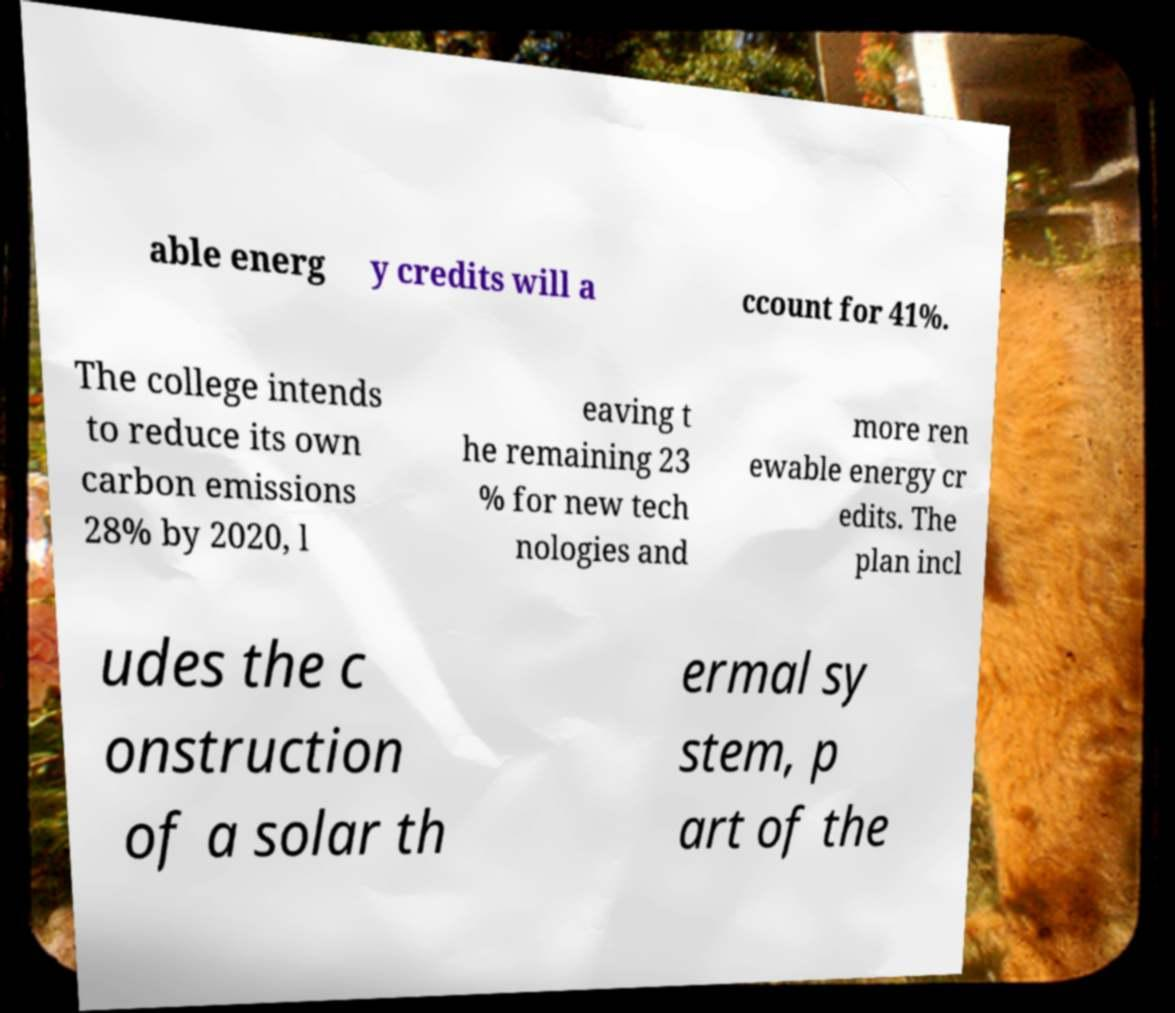Can you accurately transcribe the text from the provided image for me? able energ y credits will a ccount for 41%. The college intends to reduce its own carbon emissions 28% by 2020, l eaving t he remaining 23 % for new tech nologies and more ren ewable energy cr edits. The plan incl udes the c onstruction of a solar th ermal sy stem, p art of the 